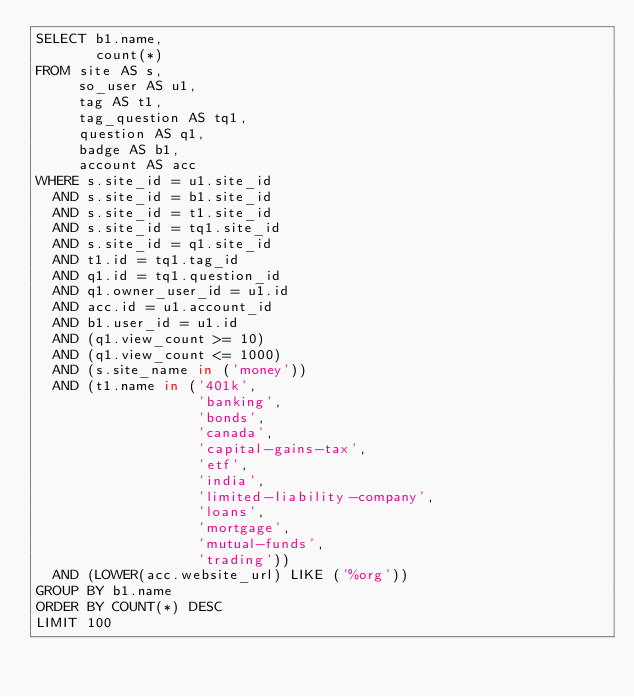Convert code to text. <code><loc_0><loc_0><loc_500><loc_500><_SQL_>SELECT b1.name,
       count(*)
FROM site AS s,
     so_user AS u1,
     tag AS t1,
     tag_question AS tq1,
     question AS q1,
     badge AS b1,
     account AS acc
WHERE s.site_id = u1.site_id
  AND s.site_id = b1.site_id
  AND s.site_id = t1.site_id
  AND s.site_id = tq1.site_id
  AND s.site_id = q1.site_id
  AND t1.id = tq1.tag_id
  AND q1.id = tq1.question_id
  AND q1.owner_user_id = u1.id
  AND acc.id = u1.account_id
  AND b1.user_id = u1.id
  AND (q1.view_count >= 10)
  AND (q1.view_count <= 1000)
  AND (s.site_name in ('money'))
  AND (t1.name in ('401k',
                   'banking',
                   'bonds',
                   'canada',
                   'capital-gains-tax',
                   'etf',
                   'india',
                   'limited-liability-company',
                   'loans',
                   'mortgage',
                   'mutual-funds',
                   'trading'))
  AND (LOWER(acc.website_url) LIKE ('%org'))
GROUP BY b1.name
ORDER BY COUNT(*) DESC
LIMIT 100</code> 